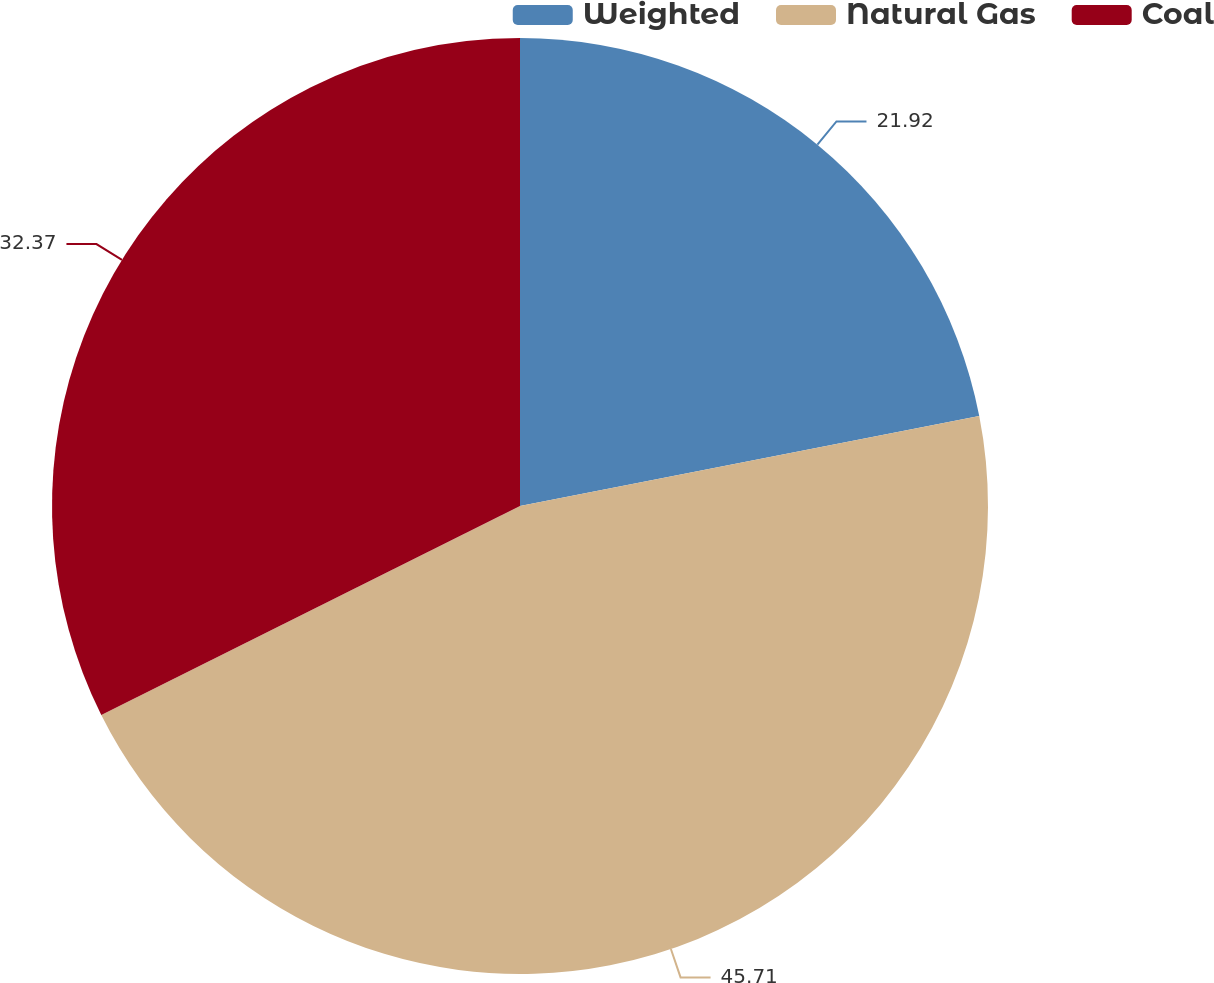Convert chart to OTSL. <chart><loc_0><loc_0><loc_500><loc_500><pie_chart><fcel>Weighted<fcel>Natural Gas<fcel>Coal<nl><fcel>21.92%<fcel>45.71%<fcel>32.37%<nl></chart> 